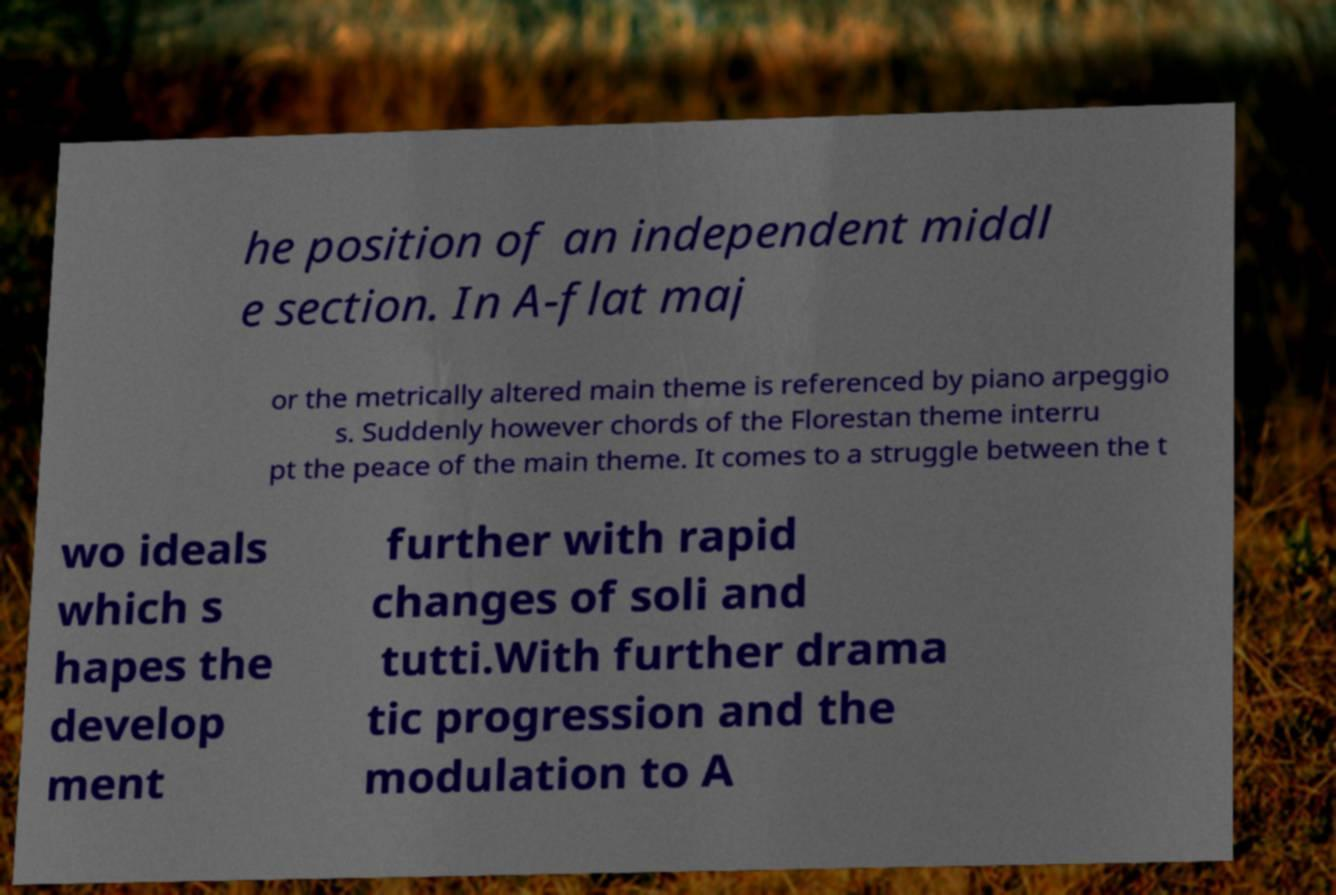For documentation purposes, I need the text within this image transcribed. Could you provide that? he position of an independent middl e section. In A-flat maj or the metrically altered main theme is referenced by piano arpeggio s. Suddenly however chords of the Florestan theme interru pt the peace of the main theme. It comes to a struggle between the t wo ideals which s hapes the develop ment further with rapid changes of soli and tutti.With further drama tic progression and the modulation to A 